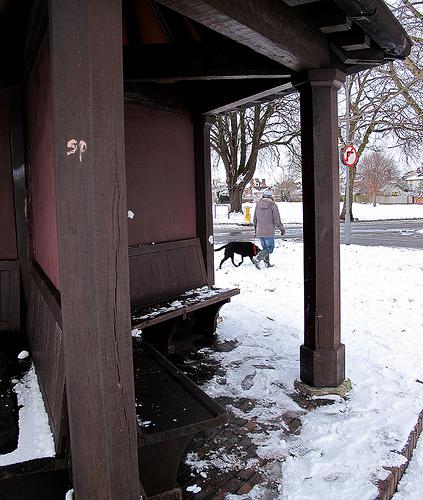What sign is in the background?
Give a very brief answer. No right turn. What is on the ground?
Give a very brief answer. Snow. Is a someone walking a dog?
Give a very brief answer. Yes. 